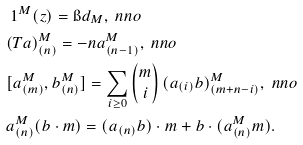<formula> <loc_0><loc_0><loc_500><loc_500>& \ 1 ^ { M } ( z ) = \i d _ { M } , \ n n o \\ & ( T a ) _ { ( n ) } ^ { M } = - n a _ { ( n - 1 ) } ^ { M } , \ n n o \\ & [ a _ { ( m ) } ^ { M } , b _ { ( n ) } ^ { M } ] = \sum _ { i \geq 0 } \begin{pmatrix} m \\ i \end{pmatrix} ( a _ { ( i ) } b ) _ { ( m + n - i ) } ^ { M } , \ n n o \\ & a _ { ( n ) } ^ { M } ( b \cdot m ) = ( a _ { ( n ) } b ) \cdot m + b \cdot ( a _ { ( n ) } ^ { M } m ) .</formula> 